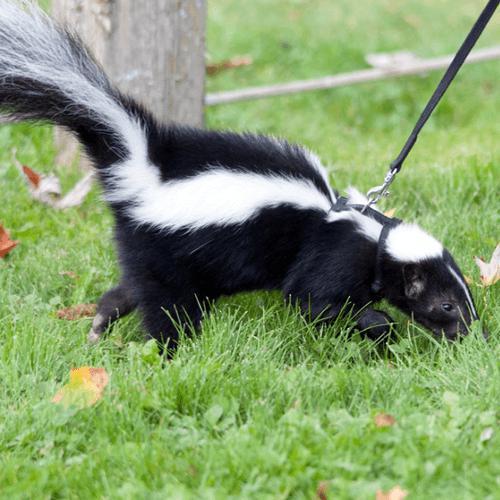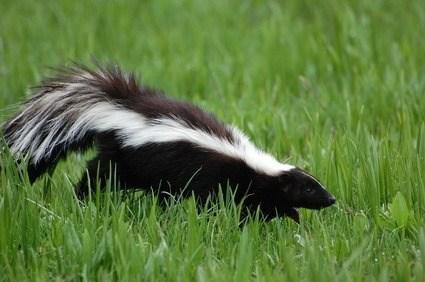The first image is the image on the left, the second image is the image on the right. Evaluate the accuracy of this statement regarding the images: "Both skunks are facing right.". Is it true? Answer yes or no. Yes. The first image is the image on the left, the second image is the image on the right. Considering the images on both sides, is "there is a skunk in the grass with dandelions growing in the grass" valid? Answer yes or no. No. 